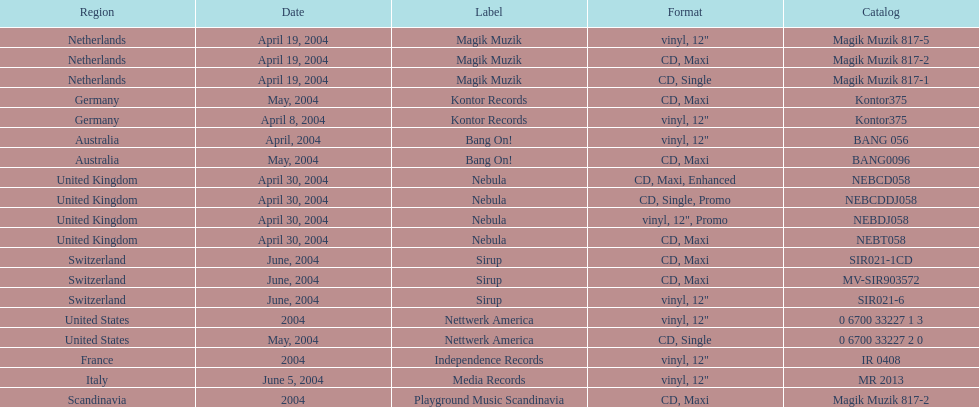What region was in the sir021-1cd catalog? Switzerland. 